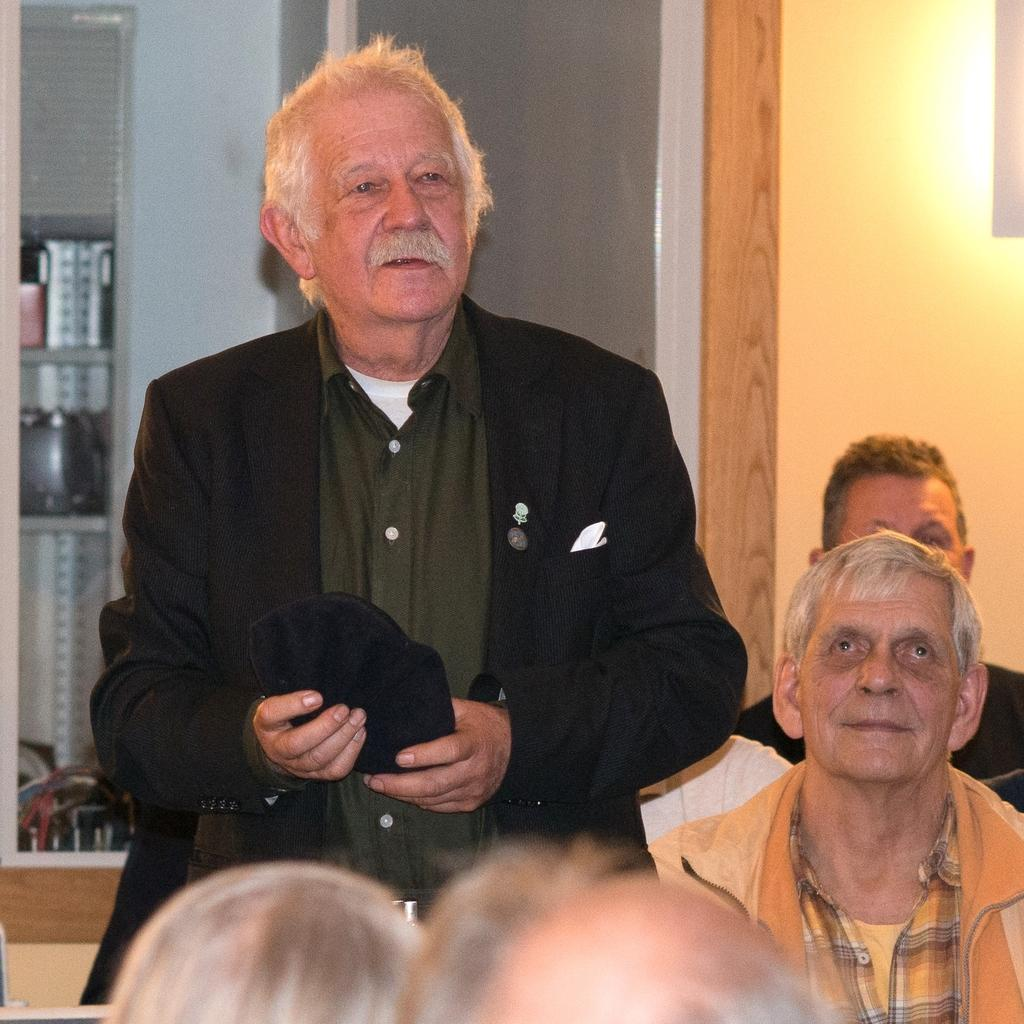What is the man in the image doing? The man is standing in the image. What are the people in the image doing? The people in the image are sitting. What can be seen behind the people in the image? There are objects visible behind the people. What is in the background of the image? There is a wall in the background of the image. What type of boot is the man wearing in the image? The man is not wearing a boot in the image; he is standing with his feet visible. How many cakes are on the table in the image? There is no table or cakes present in the image. 